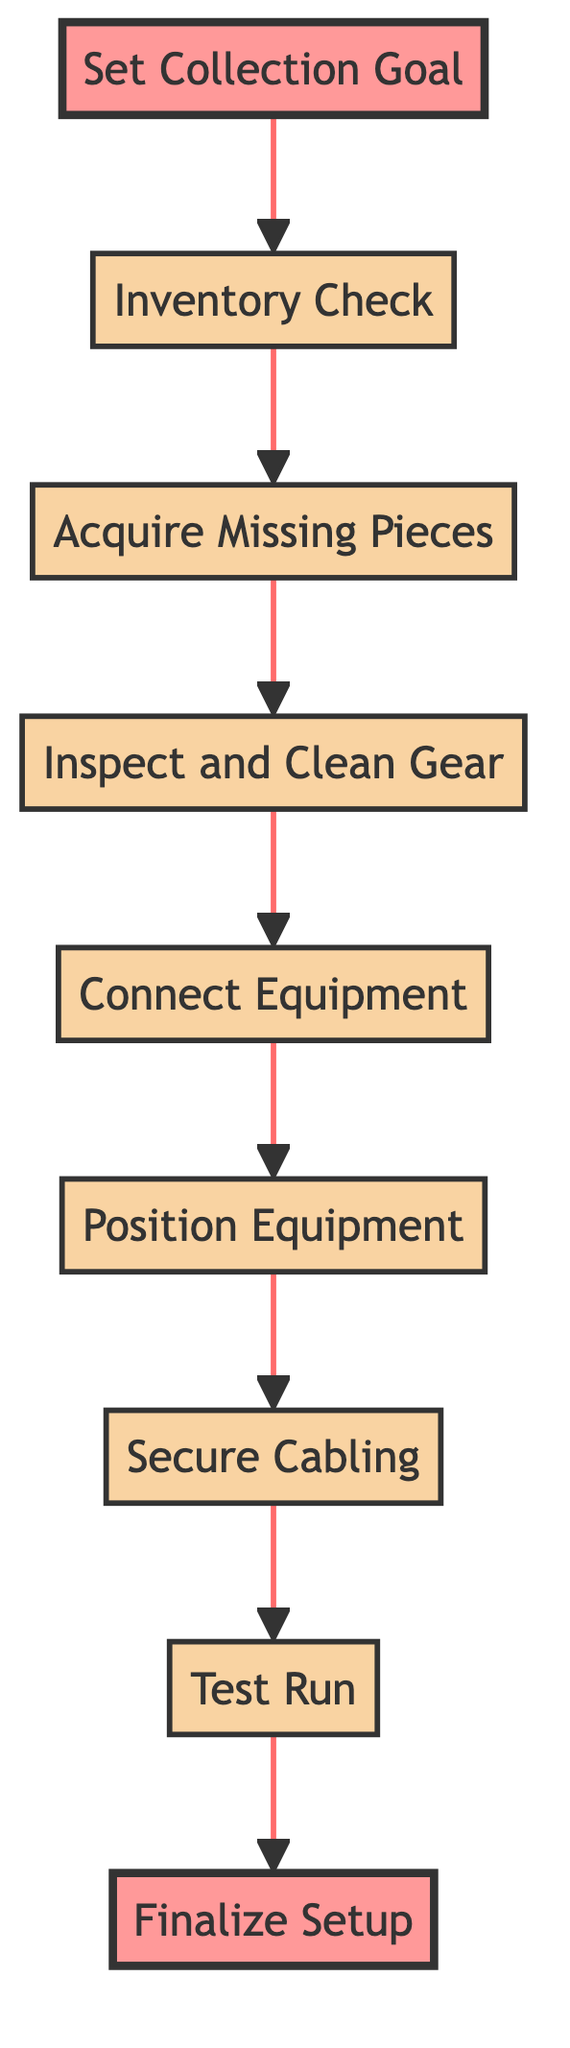What is the first step in setting up the collection? The first step in setting up the collection is to "Set Collection Goal," which is the bottom node in the diagram.
Answer: Set Collection Goal How many nodes are present in the diagram? Counting the nodes listed in the flowchart, there are nine distinct elements that represent each step in the process.
Answer: Nine What follows after "Acquire Missing Pieces"? After "Acquire Missing Pieces," the next step is "Inspect and Clean Gear," as shown by the flow of the diagram moving upwards.
Answer: Inspect and Clean Gear What is the last step in the setup process? The last step in the setup process, as indicated by the flow at the top of the diagram, is "Finalize Setup."
Answer: Finalize Setup How does "Position Equipment" relate to "Connect Equipment"? "Position Equipment" comes directly after "Connect Equipment" in the flow, meaning it is the next step in the process after connecting the various pieces of equipment.
Answer: Position Equipment What do you need to do before "Test Run"? Before conducting a "Test Run," you must complete the "Secure Cabling" step, which is directly below it in the flow hierarchy.
Answer: Secure Cabling What is the main purpose of "Inspect and Clean Gear"? The primary purpose of "Inspect and Clean Gear" is to ensure that all vintage equipment is thoroughly checked and cleaned before it is used, which is crucial for maintaining quality.
Answer: Ensure quality Which two steps come after "Inventory Check"? The two steps that follow "Inventory Check" are "Acquire Missing Pieces" and "Inspect and Clean Gear," as these are sequentially presented above it in the flow.
Answer: Acquire Missing Pieces, Inspect and Clean Gear What is the overall theme of the flowchart? The overall theme of the flowchart is the systematic approach to setting up a vintage music equipment collection, guiding through each necessary step from goal setting to final setup.
Answer: Systematic setup process 